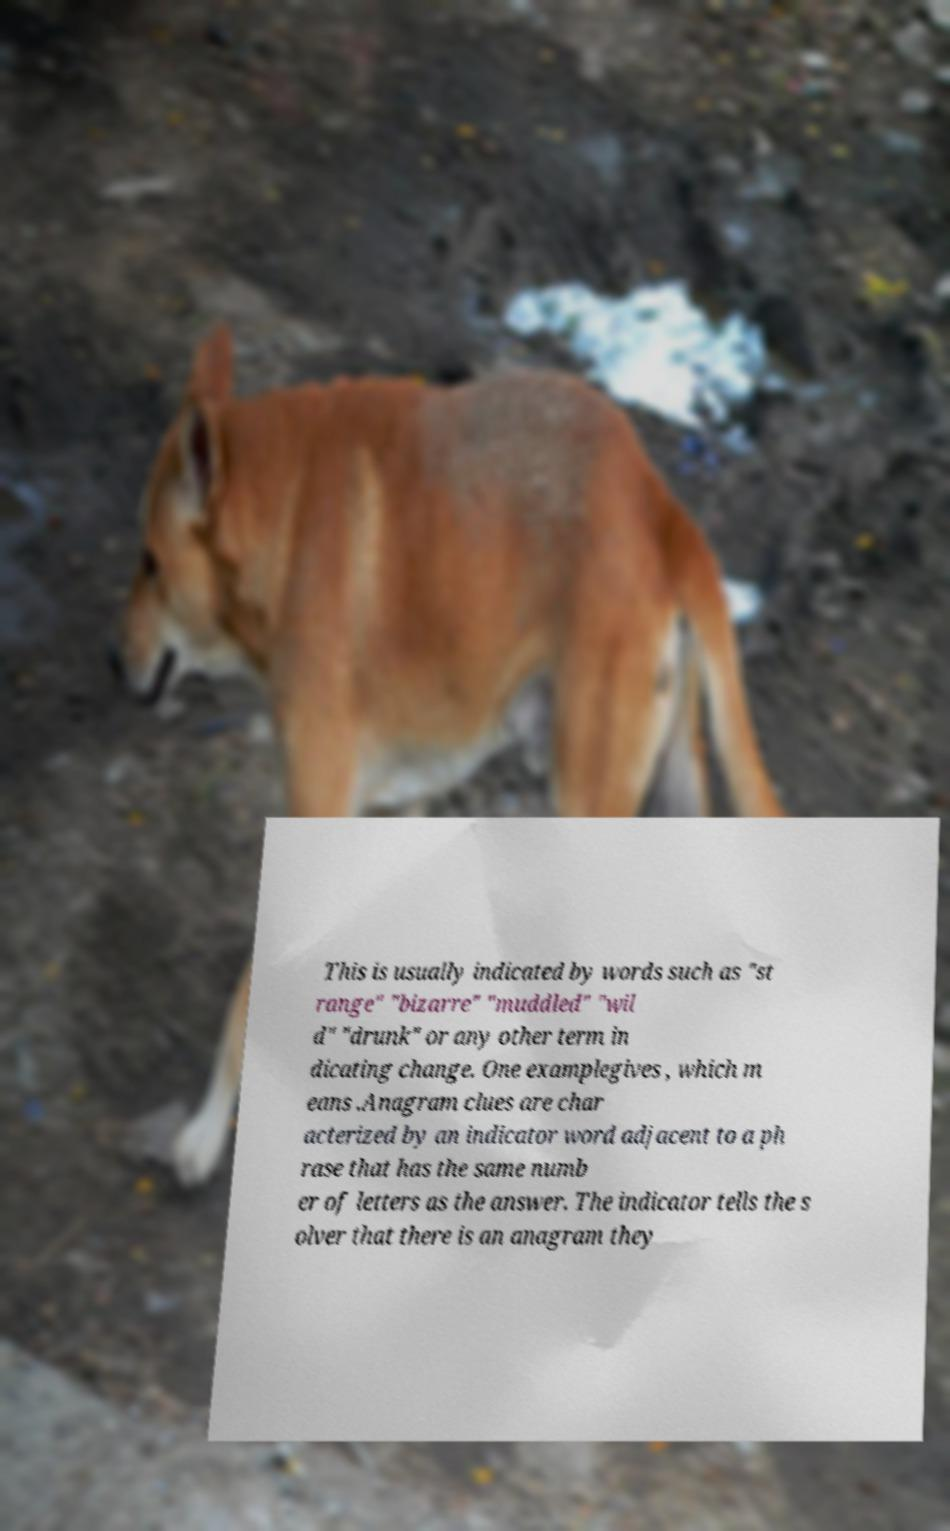Can you read and provide the text displayed in the image?This photo seems to have some interesting text. Can you extract and type it out for me? This is usually indicated by words such as "st range" "bizarre" "muddled" "wil d" "drunk" or any other term in dicating change. One examplegives , which m eans .Anagram clues are char acterized by an indicator word adjacent to a ph rase that has the same numb er of letters as the answer. The indicator tells the s olver that there is an anagram they 